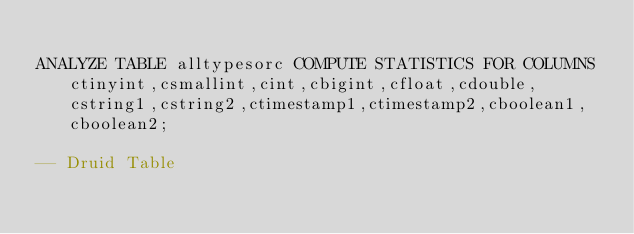Convert code to text. <code><loc_0><loc_0><loc_500><loc_500><_SQL_>
ANALYZE TABLE alltypesorc COMPUTE STATISTICS FOR COLUMNS ctinyint,csmallint,cint,cbigint,cfloat,cdouble,cstring1,cstring2,ctimestamp1,ctimestamp2,cboolean1,cboolean2;

-- Druid Table

</code> 